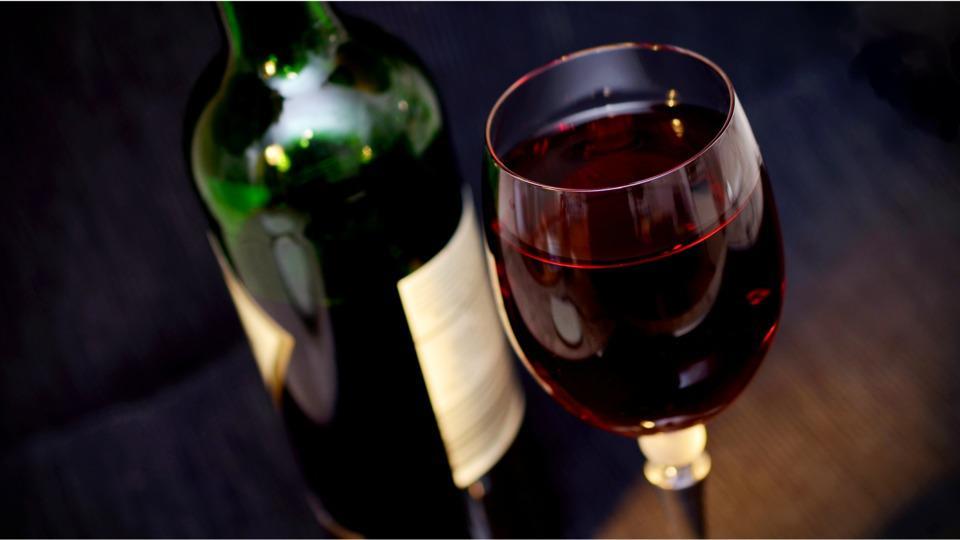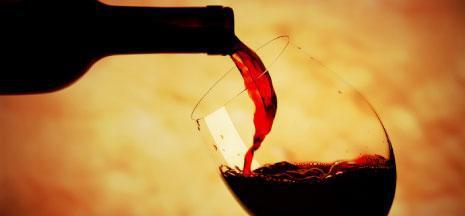The first image is the image on the left, the second image is the image on the right. For the images displayed, is the sentence "Wine is shown flowing from the bottle into the glass in exactly one image, and both images include a glass of wine and at least one bottle." factually correct? Answer yes or no. Yes. The first image is the image on the left, the second image is the image on the right. Analyze the images presented: Is the assertion "One of the images shows red wine being poured by a bottle placed at the left of the wine glass." valid? Answer yes or no. Yes. 